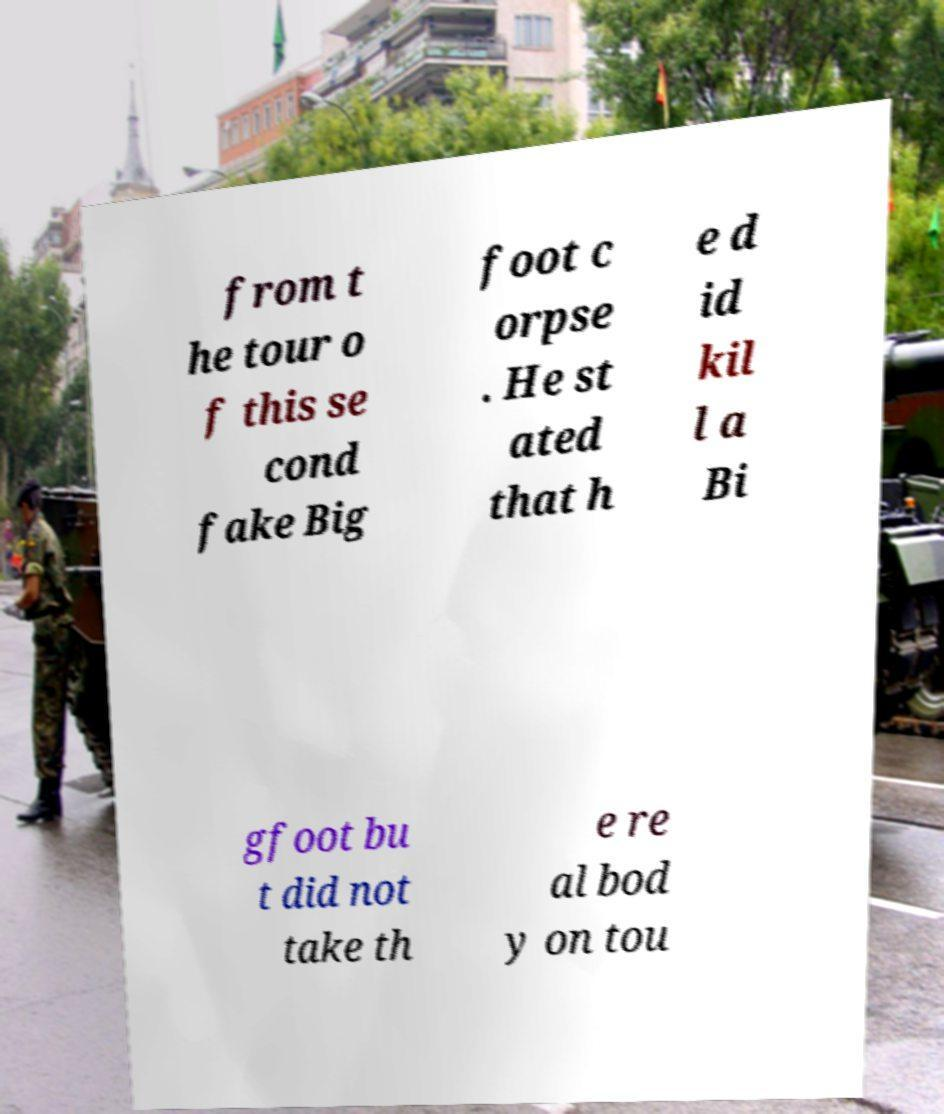Please read and relay the text visible in this image. What does it say? from t he tour o f this se cond fake Big foot c orpse . He st ated that h e d id kil l a Bi gfoot bu t did not take th e re al bod y on tou 